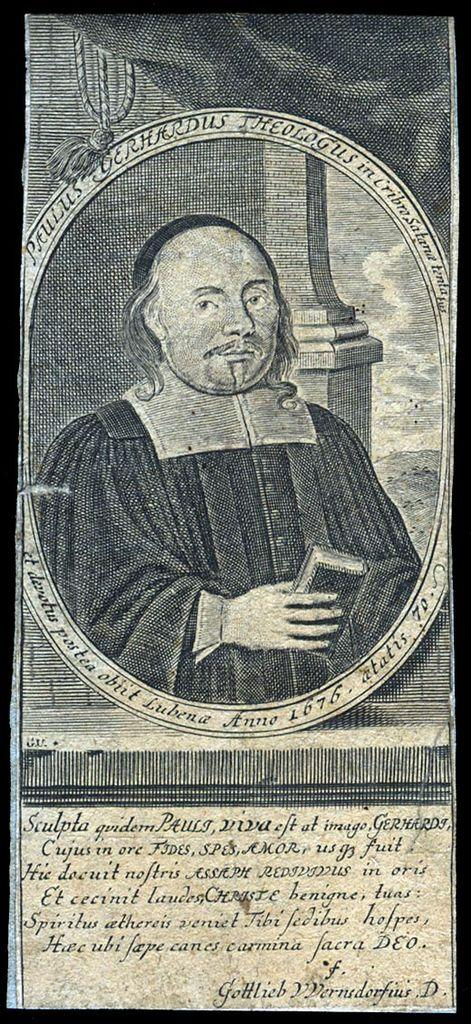What type of image is being described? The image is a page cover. Can you describe the main subject of the image? There is a person in the picture. Is there any text present on the page cover? Yes, there is text at the bottom of the image. How is the image framed? The picture has a black border. Where is the scarecrow located in the image? There is no scarecrow present in the image. What was the afterthought when designing the page cover? The provided facts do not mention any afterthoughts in the design process. Can you describe the sink featured in the image? There is no sink present in the image. 